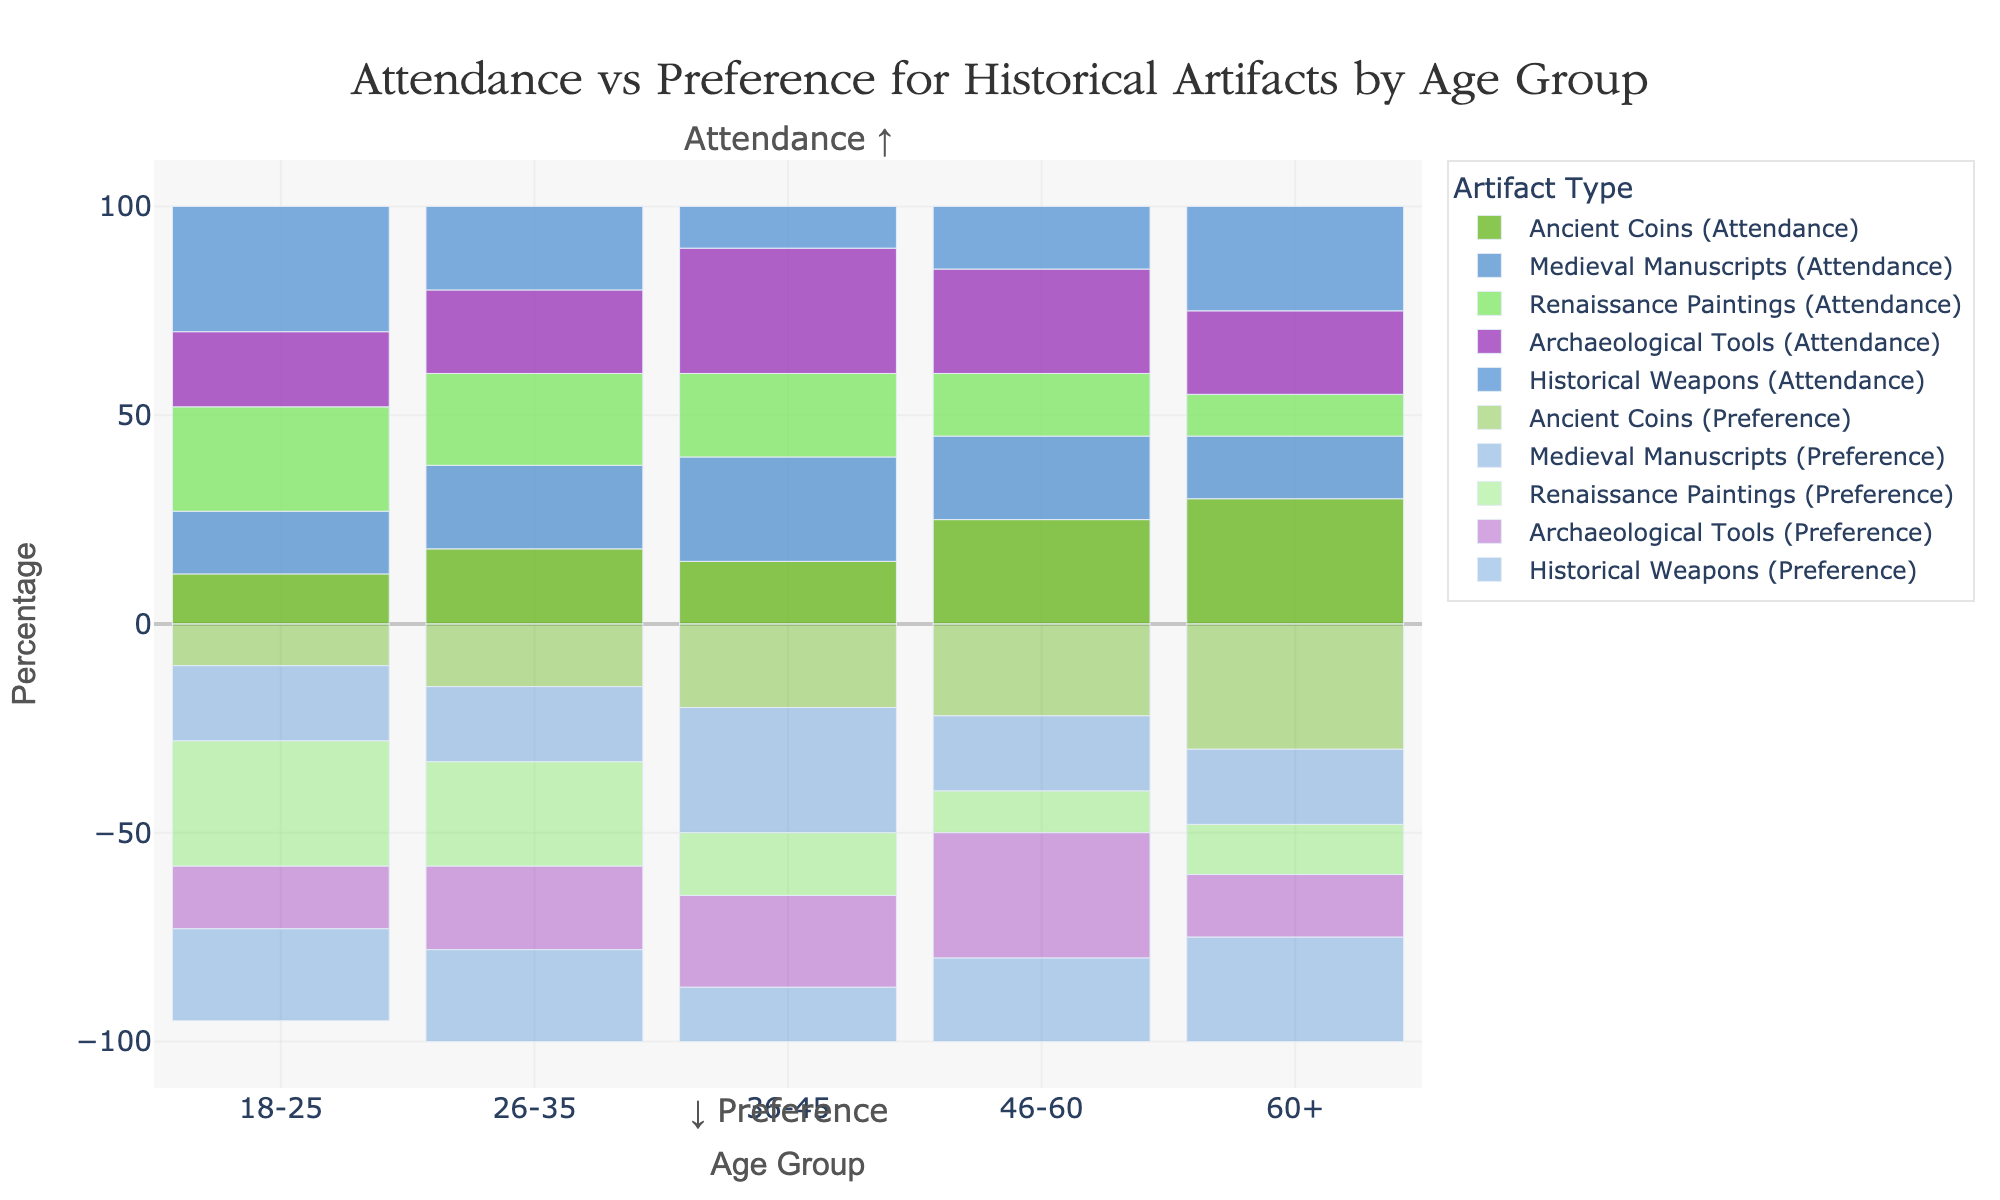Which age group has the highest attendance percentage for Renaissance Paintings? To find the age group with the highest attendance percentage for Renaissance Paintings, identify the height of the bars corresponding to each age group. The highest bar for Renaissance Paintings indicates the age group 18-25 with 25%.
Answer: 18-25 Which age group shows a higher preference percentage for Medieval Manuscripts over Archaeological Tools? To determine the age group with a higher preference for Medieval Manuscripts over Archaeological Tools, compare the heights of the negatively represented bars (since preference percentages are shown negatively) for each age group. For the age group 36-45, the Medieval Manuscripts preference is 30%, and Archaeological Tools is 22%, showing a higher preference for Medieval Manuscripts.
Answer: 36-45 Between the age groups 26-35 and 46-60, which one shows a higher attendance for Historical Weapons? Compare the bar heights of Historical Weapons for the age groups 26-35 and 46-60. The attendance percentage for age group 26-35 is 20%, and for age group 46-60 is 15%, indicating a higher attendance for 26-35.
Answer: 26-35 What is the overall difference between attendance and preference for Ancient Coins among the 60+ age group? To find the overall difference, subtract the preference percentage from the attendance percentage for the 60+ group: 30% (attendance) - 30% (preference). The difference is 0%.
Answer: 0% Which artifact type exhibits the highest preference among the 18-25 age group? Identify the highest preference bar (displayed negatively) within the 18-25 age group. Renaissance Paintings, with a preference of 30%, is the highest.
Answer: Renaissance Paintings What is the combined attendance percentage for Archaeological Tools and Historical Weapons for the 36-45 age group? Sum the attendance percentages: Archaeological Tools (30%) + Historical Weapons (10%) = 40%.
Answer: 40% Which age group shows an equal percentage of attendance for Renaissance Paintings and Historical Weapons? Look for the bars with identical heights for Renaissance Paintings and Historical Weapons across all age groups. The age group 26-35 has both percentages at 22%.
Answer: 26-35 Between the age groups 26-35 and 36-45, which one has a lower preference for Renaissance Paintings? Compare the negative bar lengths (indicating preferences) for Renaissance Paintings. The preference percentage for 26-35 is 25%, and for 36-45 is 15%. Therefore, the age group 36-45 has a lower preference.
Answer: 36-45 